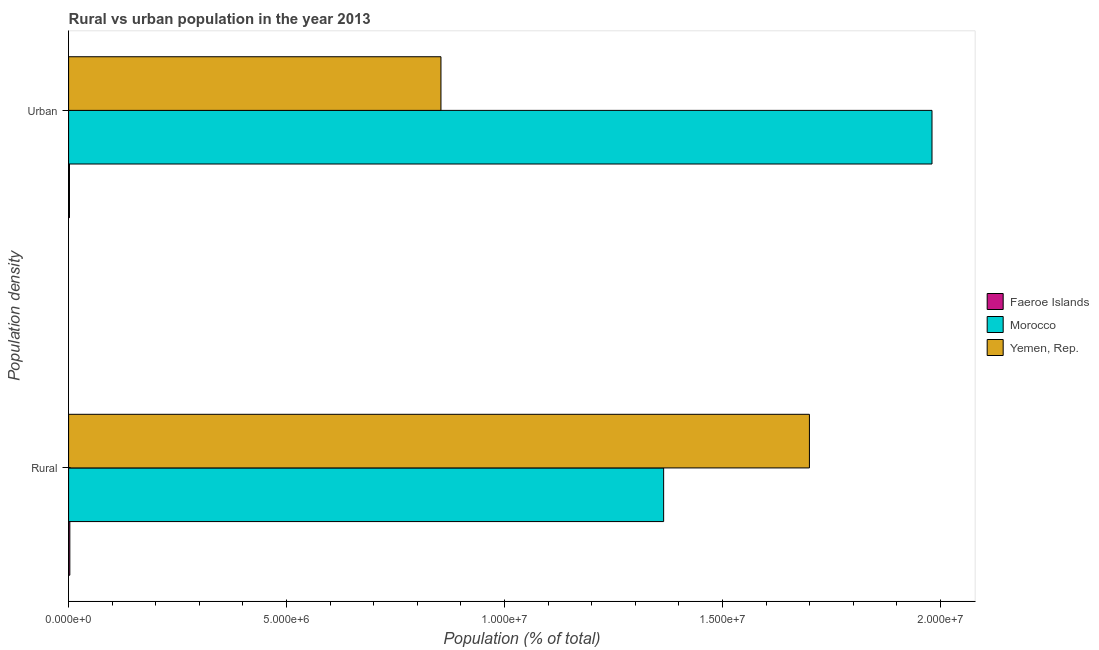How many different coloured bars are there?
Your answer should be very brief. 3. Are the number of bars per tick equal to the number of legend labels?
Your answer should be compact. Yes. How many bars are there on the 1st tick from the top?
Provide a short and direct response. 3. How many bars are there on the 2nd tick from the bottom?
Ensure brevity in your answer.  3. What is the label of the 2nd group of bars from the top?
Offer a very short reply. Rural. What is the rural population density in Morocco?
Keep it short and to the point. 1.36e+07. Across all countries, what is the maximum urban population density?
Provide a short and direct response. 1.98e+07. Across all countries, what is the minimum rural population density?
Ensure brevity in your answer.  2.82e+04. In which country was the urban population density maximum?
Offer a very short reply. Morocco. In which country was the urban population density minimum?
Your answer should be very brief. Faeroe Islands. What is the total rural population density in the graph?
Offer a very short reply. 3.07e+07. What is the difference between the urban population density in Yemen, Rep. and that in Faeroe Islands?
Your answer should be very brief. 8.52e+06. What is the difference between the urban population density in Yemen, Rep. and the rural population density in Morocco?
Ensure brevity in your answer.  -5.11e+06. What is the average rural population density per country?
Provide a short and direct response. 1.02e+07. What is the difference between the rural population density and urban population density in Yemen, Rep.?
Make the answer very short. 8.45e+06. What is the ratio of the rural population density in Faeroe Islands to that in Morocco?
Keep it short and to the point. 0. Is the urban population density in Yemen, Rep. less than that in Faeroe Islands?
Provide a succinct answer. No. What does the 2nd bar from the top in Urban represents?
Your answer should be very brief. Morocco. What does the 1st bar from the bottom in Urban represents?
Offer a terse response. Faeroe Islands. Are all the bars in the graph horizontal?
Ensure brevity in your answer.  Yes. How many countries are there in the graph?
Provide a succinct answer. 3. Does the graph contain any zero values?
Your answer should be very brief. No. Does the graph contain grids?
Your answer should be very brief. No. What is the title of the graph?
Keep it short and to the point. Rural vs urban population in the year 2013. What is the label or title of the X-axis?
Offer a terse response. Population (% of total). What is the label or title of the Y-axis?
Give a very brief answer. Population density. What is the Population (% of total) of Faeroe Islands in Rural?
Keep it short and to the point. 2.82e+04. What is the Population (% of total) in Morocco in Rural?
Offer a terse response. 1.36e+07. What is the Population (% of total) in Yemen, Rep. in Rural?
Ensure brevity in your answer.  1.70e+07. What is the Population (% of total) of Faeroe Islands in Urban?
Offer a terse response. 2.01e+04. What is the Population (% of total) of Morocco in Urban?
Make the answer very short. 1.98e+07. What is the Population (% of total) of Yemen, Rep. in Urban?
Offer a very short reply. 8.54e+06. Across all Population density, what is the maximum Population (% of total) of Faeroe Islands?
Give a very brief answer. 2.82e+04. Across all Population density, what is the maximum Population (% of total) of Morocco?
Ensure brevity in your answer.  1.98e+07. Across all Population density, what is the maximum Population (% of total) in Yemen, Rep.?
Provide a succinct answer. 1.70e+07. Across all Population density, what is the minimum Population (% of total) of Faeroe Islands?
Offer a terse response. 2.01e+04. Across all Population density, what is the minimum Population (% of total) in Morocco?
Ensure brevity in your answer.  1.36e+07. Across all Population density, what is the minimum Population (% of total) in Yemen, Rep.?
Your answer should be very brief. 8.54e+06. What is the total Population (% of total) in Faeroe Islands in the graph?
Offer a very short reply. 4.83e+04. What is the total Population (% of total) in Morocco in the graph?
Offer a terse response. 3.35e+07. What is the total Population (% of total) of Yemen, Rep. in the graph?
Ensure brevity in your answer.  2.55e+07. What is the difference between the Population (% of total) of Faeroe Islands in Rural and that in Urban?
Your response must be concise. 8180. What is the difference between the Population (% of total) in Morocco in Rural and that in Urban?
Give a very brief answer. -6.16e+06. What is the difference between the Population (% of total) in Yemen, Rep. in Rural and that in Urban?
Provide a succinct answer. 8.45e+06. What is the difference between the Population (% of total) of Faeroe Islands in Rural and the Population (% of total) of Morocco in Urban?
Give a very brief answer. -1.98e+07. What is the difference between the Population (% of total) in Faeroe Islands in Rural and the Population (% of total) in Yemen, Rep. in Urban?
Ensure brevity in your answer.  -8.51e+06. What is the difference between the Population (% of total) in Morocco in Rural and the Population (% of total) in Yemen, Rep. in Urban?
Provide a succinct answer. 5.11e+06. What is the average Population (% of total) of Faeroe Islands per Population density?
Your response must be concise. 2.41e+04. What is the average Population (% of total) in Morocco per Population density?
Keep it short and to the point. 1.67e+07. What is the average Population (% of total) in Yemen, Rep. per Population density?
Offer a terse response. 1.28e+07. What is the difference between the Population (% of total) of Faeroe Islands and Population (% of total) of Morocco in Rural?
Your answer should be compact. -1.36e+07. What is the difference between the Population (% of total) in Faeroe Islands and Population (% of total) in Yemen, Rep. in Rural?
Offer a terse response. -1.70e+07. What is the difference between the Population (% of total) of Morocco and Population (% of total) of Yemen, Rep. in Rural?
Offer a very short reply. -3.34e+06. What is the difference between the Population (% of total) of Faeroe Islands and Population (% of total) of Morocco in Urban?
Provide a short and direct response. -1.98e+07. What is the difference between the Population (% of total) in Faeroe Islands and Population (% of total) in Yemen, Rep. in Urban?
Offer a terse response. -8.52e+06. What is the difference between the Population (% of total) in Morocco and Population (% of total) in Yemen, Rep. in Urban?
Your answer should be compact. 1.13e+07. What is the ratio of the Population (% of total) in Faeroe Islands in Rural to that in Urban?
Give a very brief answer. 1.41. What is the ratio of the Population (% of total) of Morocco in Rural to that in Urban?
Provide a succinct answer. 0.69. What is the ratio of the Population (% of total) of Yemen, Rep. in Rural to that in Urban?
Keep it short and to the point. 1.99. What is the difference between the highest and the second highest Population (% of total) of Faeroe Islands?
Offer a terse response. 8180. What is the difference between the highest and the second highest Population (% of total) in Morocco?
Your response must be concise. 6.16e+06. What is the difference between the highest and the second highest Population (% of total) of Yemen, Rep.?
Your response must be concise. 8.45e+06. What is the difference between the highest and the lowest Population (% of total) in Faeroe Islands?
Your response must be concise. 8180. What is the difference between the highest and the lowest Population (% of total) of Morocco?
Your answer should be very brief. 6.16e+06. What is the difference between the highest and the lowest Population (% of total) in Yemen, Rep.?
Provide a succinct answer. 8.45e+06. 